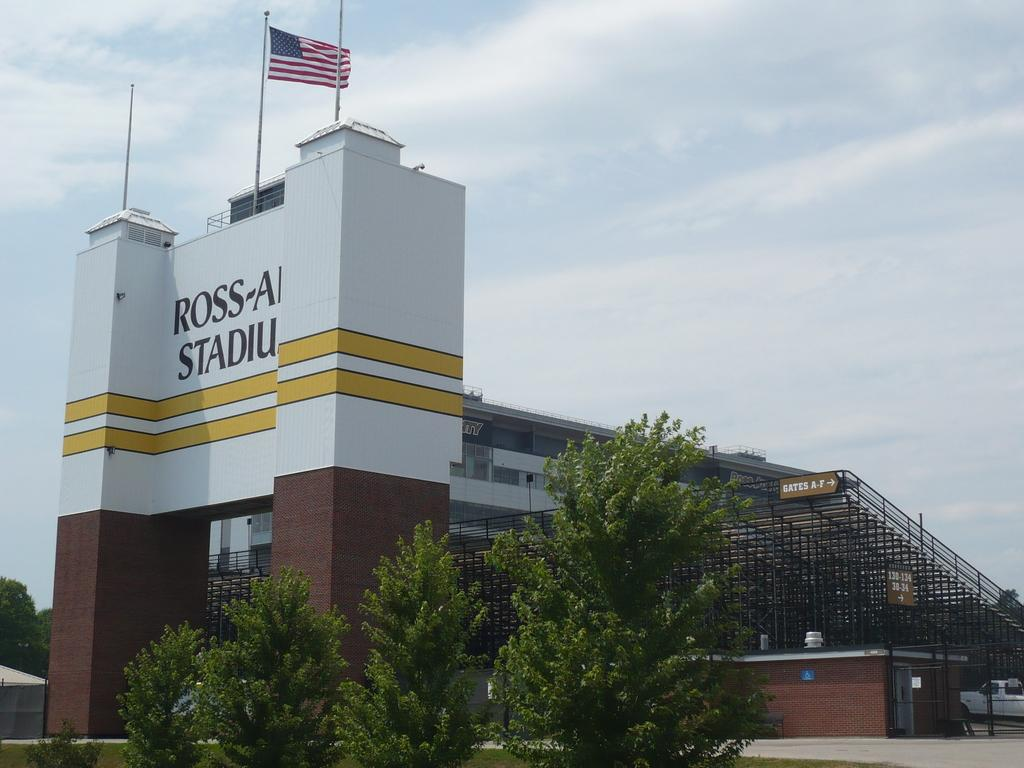<image>
Offer a succinct explanation of the picture presented. A stadium's name starts with the word Ross and there is an American flag on top of the sign. 